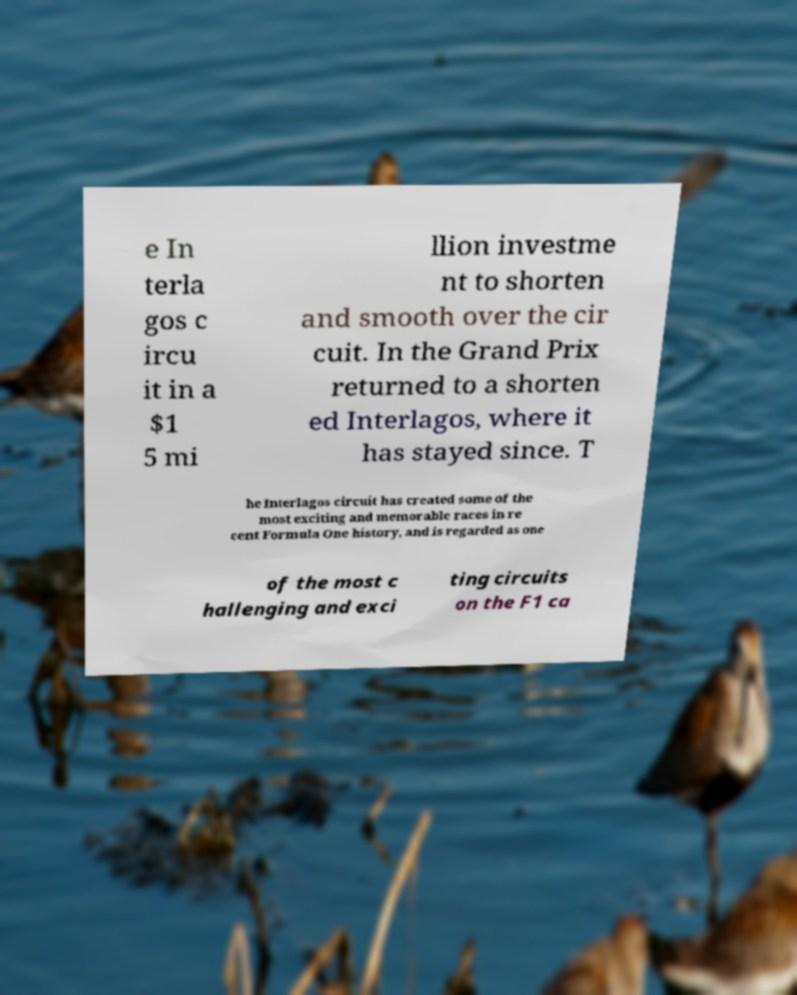Please identify and transcribe the text found in this image. e In terla gos c ircu it in a $1 5 mi llion investme nt to shorten and smooth over the cir cuit. In the Grand Prix returned to a shorten ed Interlagos, where it has stayed since. T he Interlagos circuit has created some of the most exciting and memorable races in re cent Formula One history, and is regarded as one of the most c hallenging and exci ting circuits on the F1 ca 